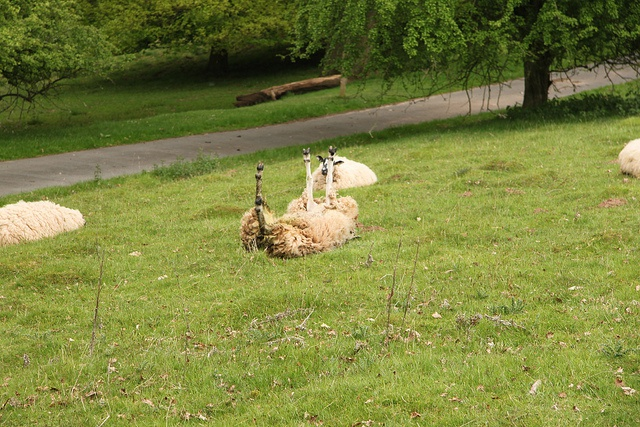Describe the objects in this image and their specific colors. I can see sheep in darkgreen, tan, and beige tones, sheep in darkgreen, beige, and tan tones, sheep in darkgreen, beige, and tan tones, bird in darkgreen, tan, and beige tones, and sheep in darkgreen, tan, and ivory tones in this image. 